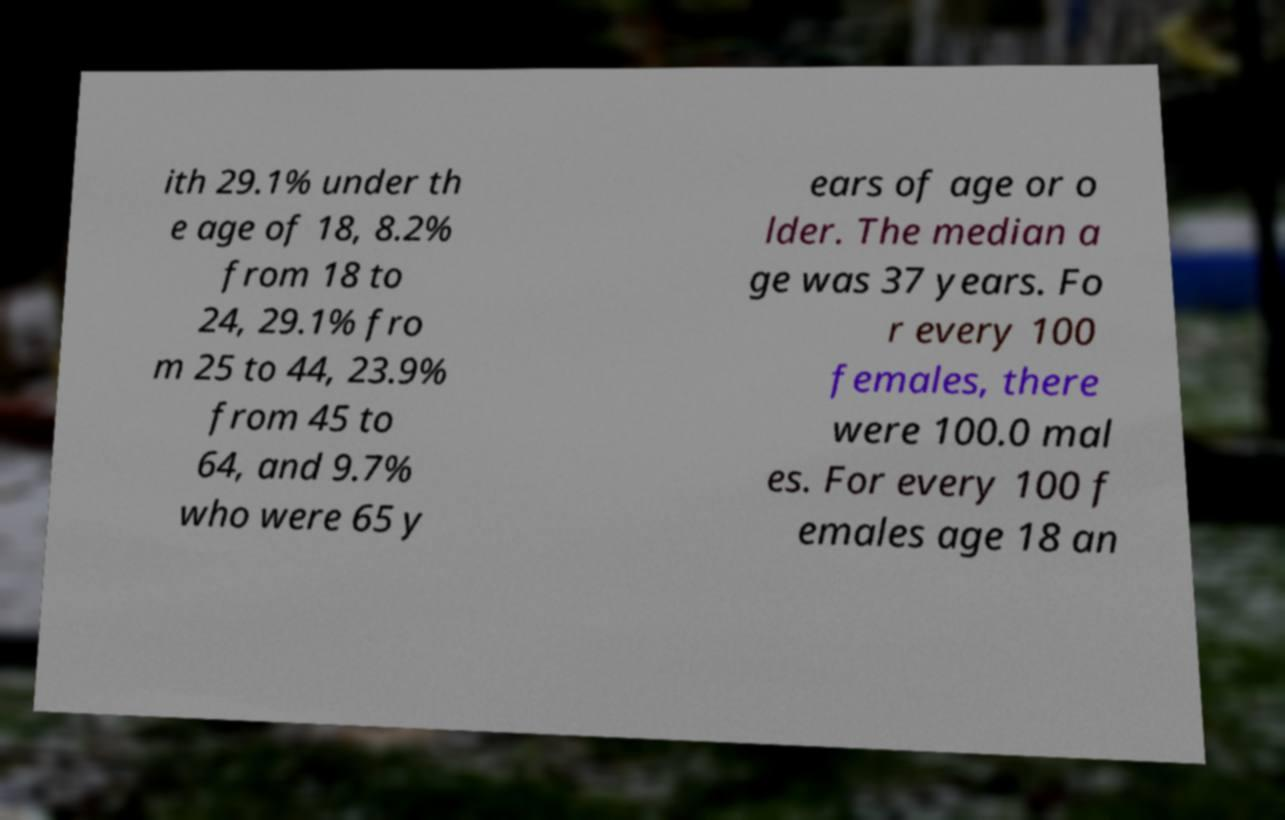Could you extract and type out the text from this image? ith 29.1% under th e age of 18, 8.2% from 18 to 24, 29.1% fro m 25 to 44, 23.9% from 45 to 64, and 9.7% who were 65 y ears of age or o lder. The median a ge was 37 years. Fo r every 100 females, there were 100.0 mal es. For every 100 f emales age 18 an 